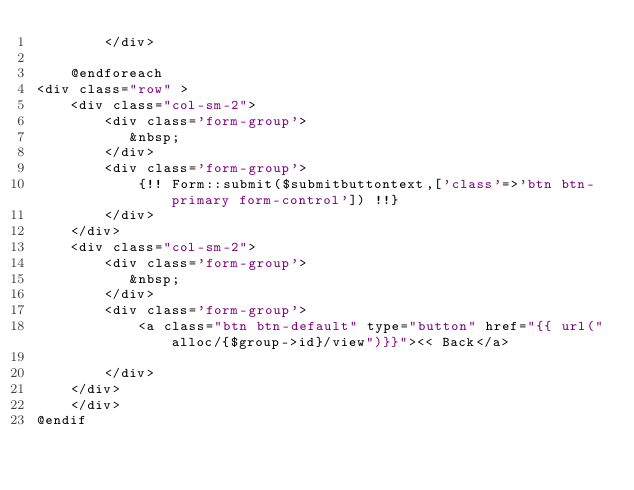<code> <loc_0><loc_0><loc_500><loc_500><_PHP_>        </div>

    @endforeach
<div class="row" >
    <div class="col-sm-2">
        <div class='form-group'>
           &nbsp;
        </div>
        <div class='form-group'>
            {!! Form::submit($submitbuttontext,['class'=>'btn btn-primary form-control']) !!}
        </div>
    </div>
    <div class="col-sm-2">
        <div class='form-group'>
           &nbsp;
        </div>
        <div class='form-group'>
            <a class="btn btn-default" type="button" href="{{ url("alloc/{$group->id}/view")}}"><< Back</a>

        </div>
    </div>
    </div>
@endif




</code> 